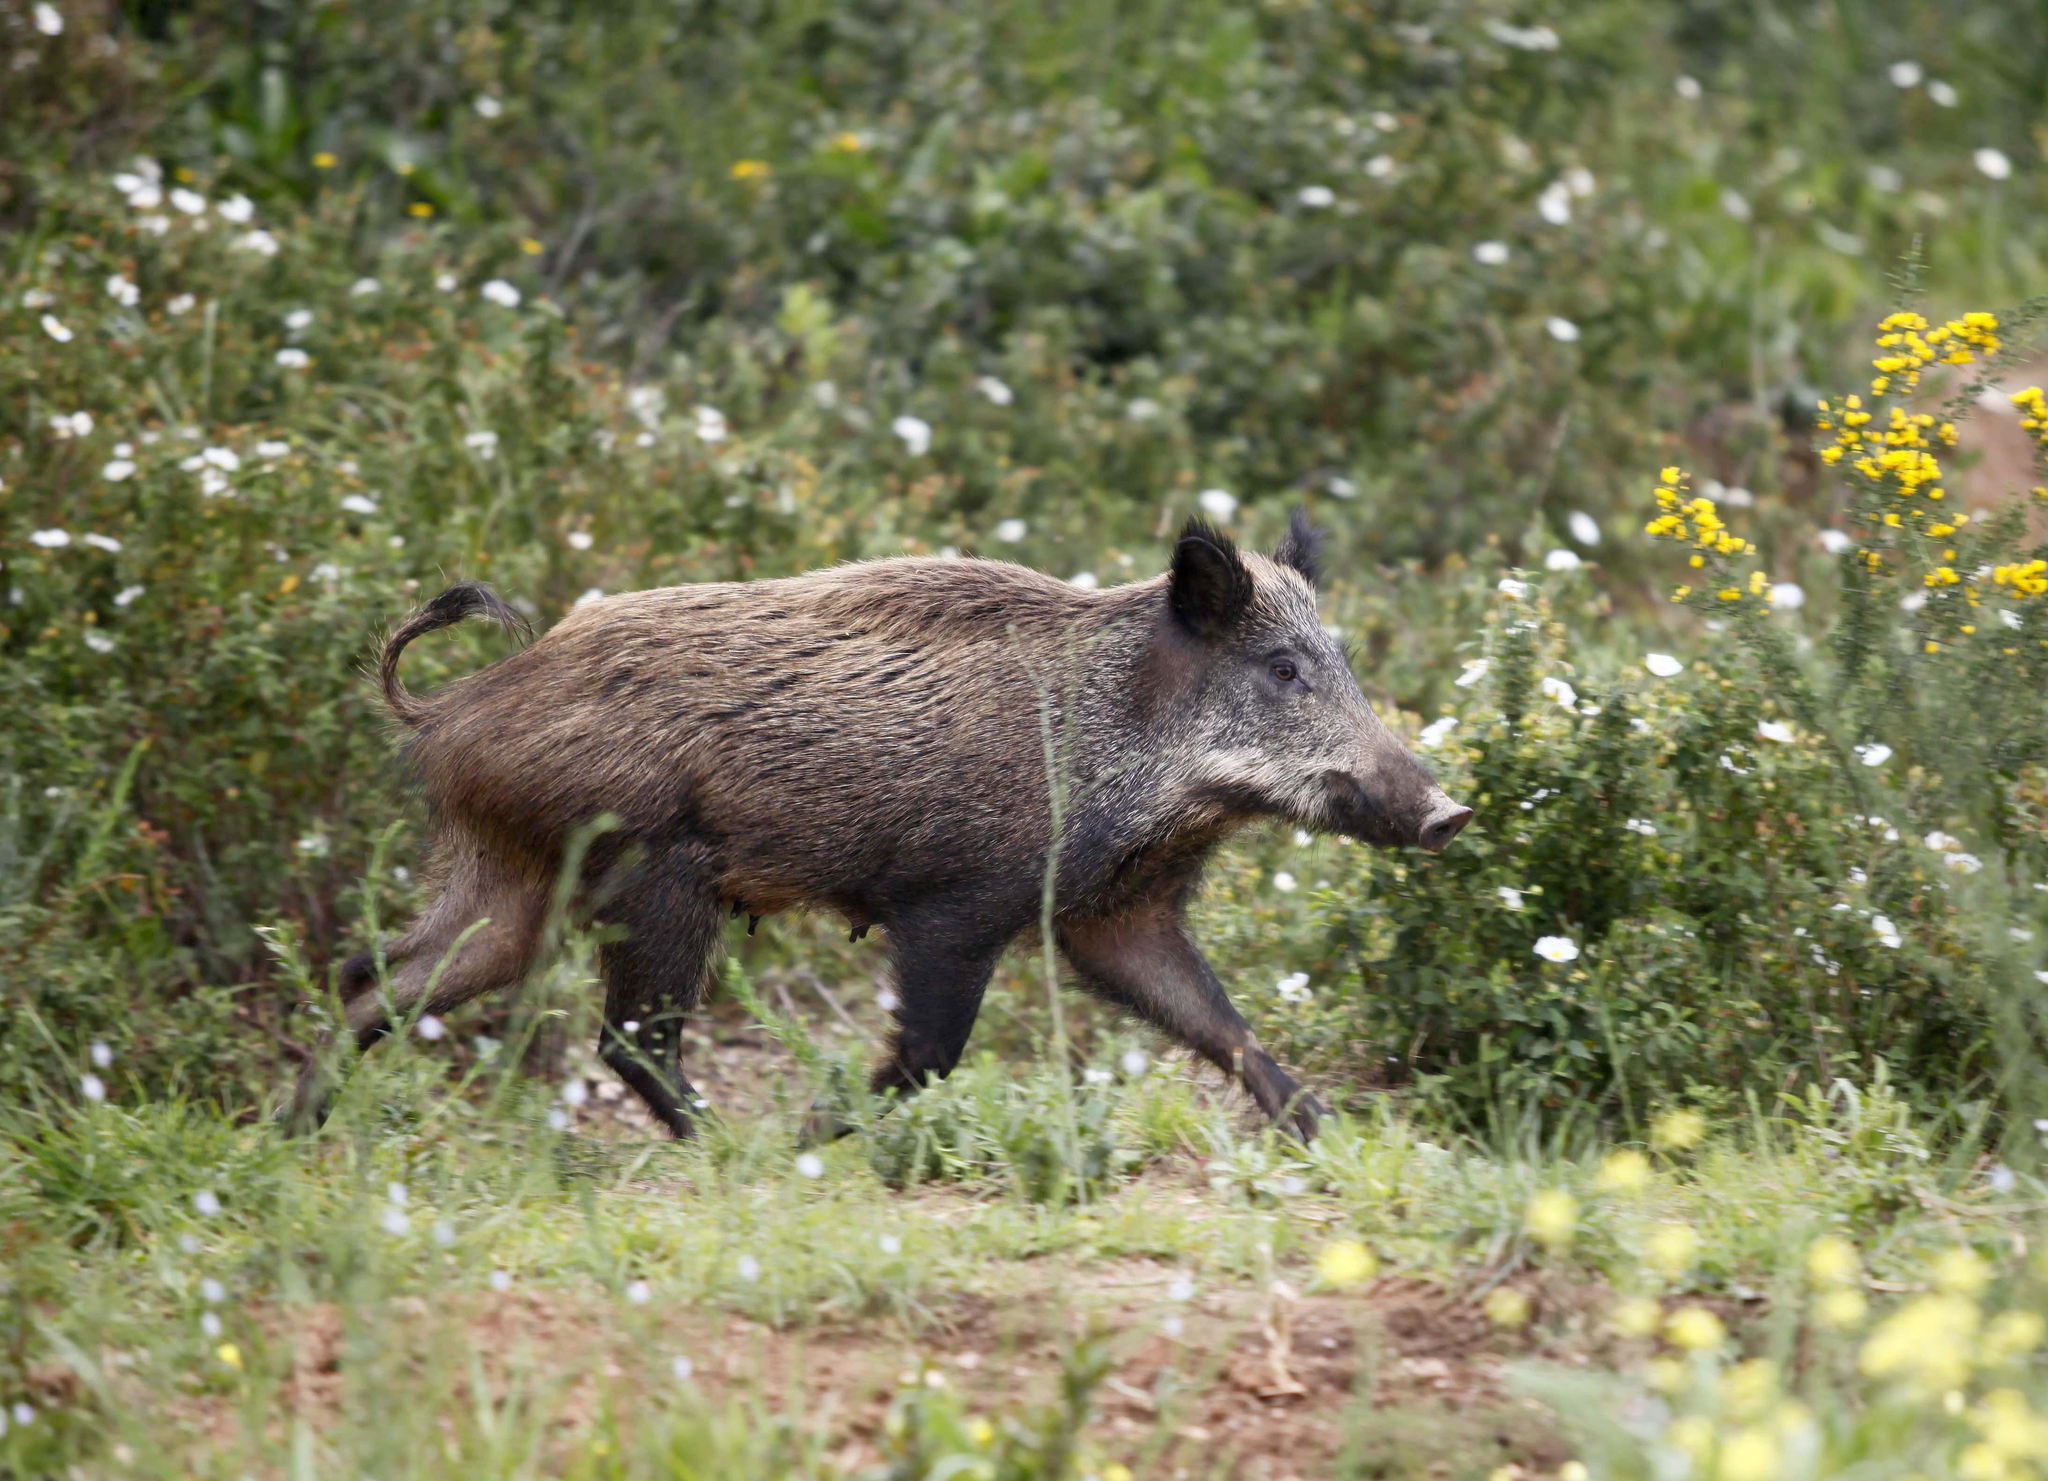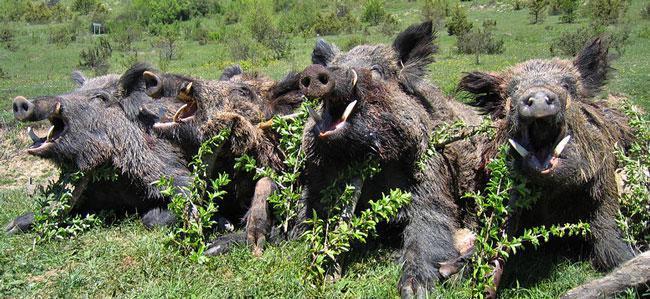The first image is the image on the left, the second image is the image on the right. Evaluate the accuracy of this statement regarding the images: "At least one of the animals pictured is dead.". Is it true? Answer yes or no. No. 